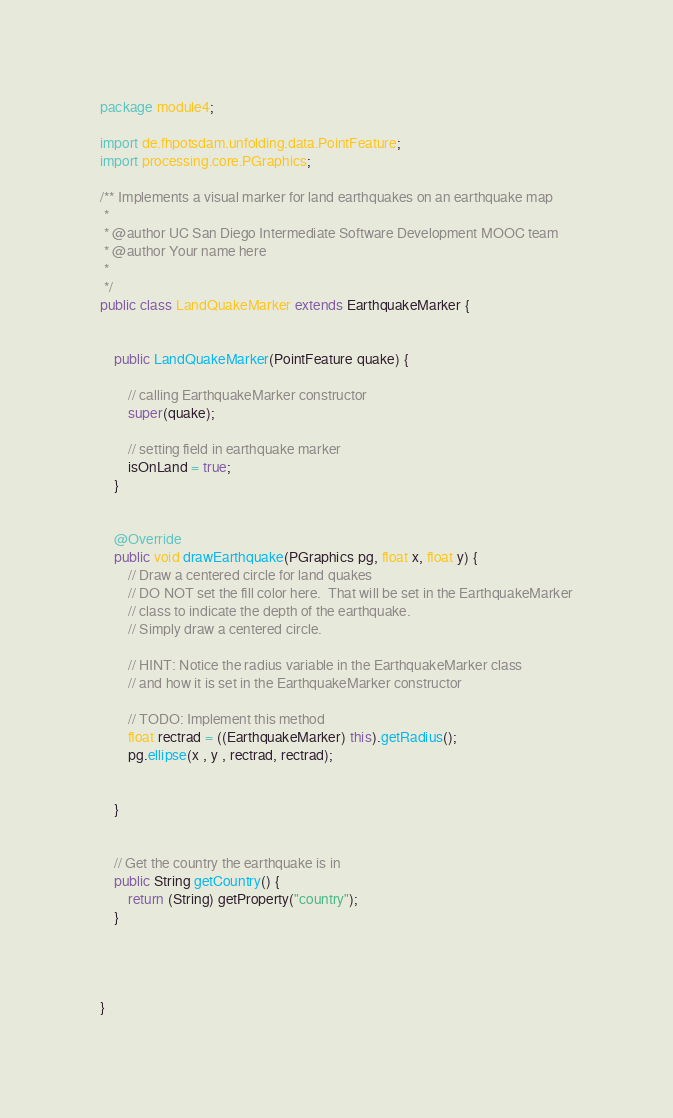Convert code to text. <code><loc_0><loc_0><loc_500><loc_500><_Java_>package module4;

import de.fhpotsdam.unfolding.data.PointFeature;
import processing.core.PGraphics;

/** Implements a visual marker for land earthquakes on an earthquake map
 * 
 * @author UC San Diego Intermediate Software Development MOOC team
 * @author Your name here
 *
 */
public class LandQuakeMarker extends EarthquakeMarker {
	
	
	public LandQuakeMarker(PointFeature quake) {
		
		// calling EarthquakeMarker constructor
		super(quake);
		
		// setting field in earthquake marker
		isOnLand = true;
	}


	@Override
	public void drawEarthquake(PGraphics pg, float x, float y) {
		// Draw a centered circle for land quakes
		// DO NOT set the fill color here.  That will be set in the EarthquakeMarker
		// class to indicate the depth of the earthquake.
		// Simply draw a centered circle.
		
		// HINT: Notice the radius variable in the EarthquakeMarker class
		// and how it is set in the EarthquakeMarker constructor
		
		// TODO: Implement this method
		float rectrad = ((EarthquakeMarker) this).getRadius();
		pg.ellipse(x , y , rectrad, rectrad);
		
		
	}
	

	// Get the country the earthquake is in
	public String getCountry() {
		return (String) getProperty("country");
	}



		
}</code> 